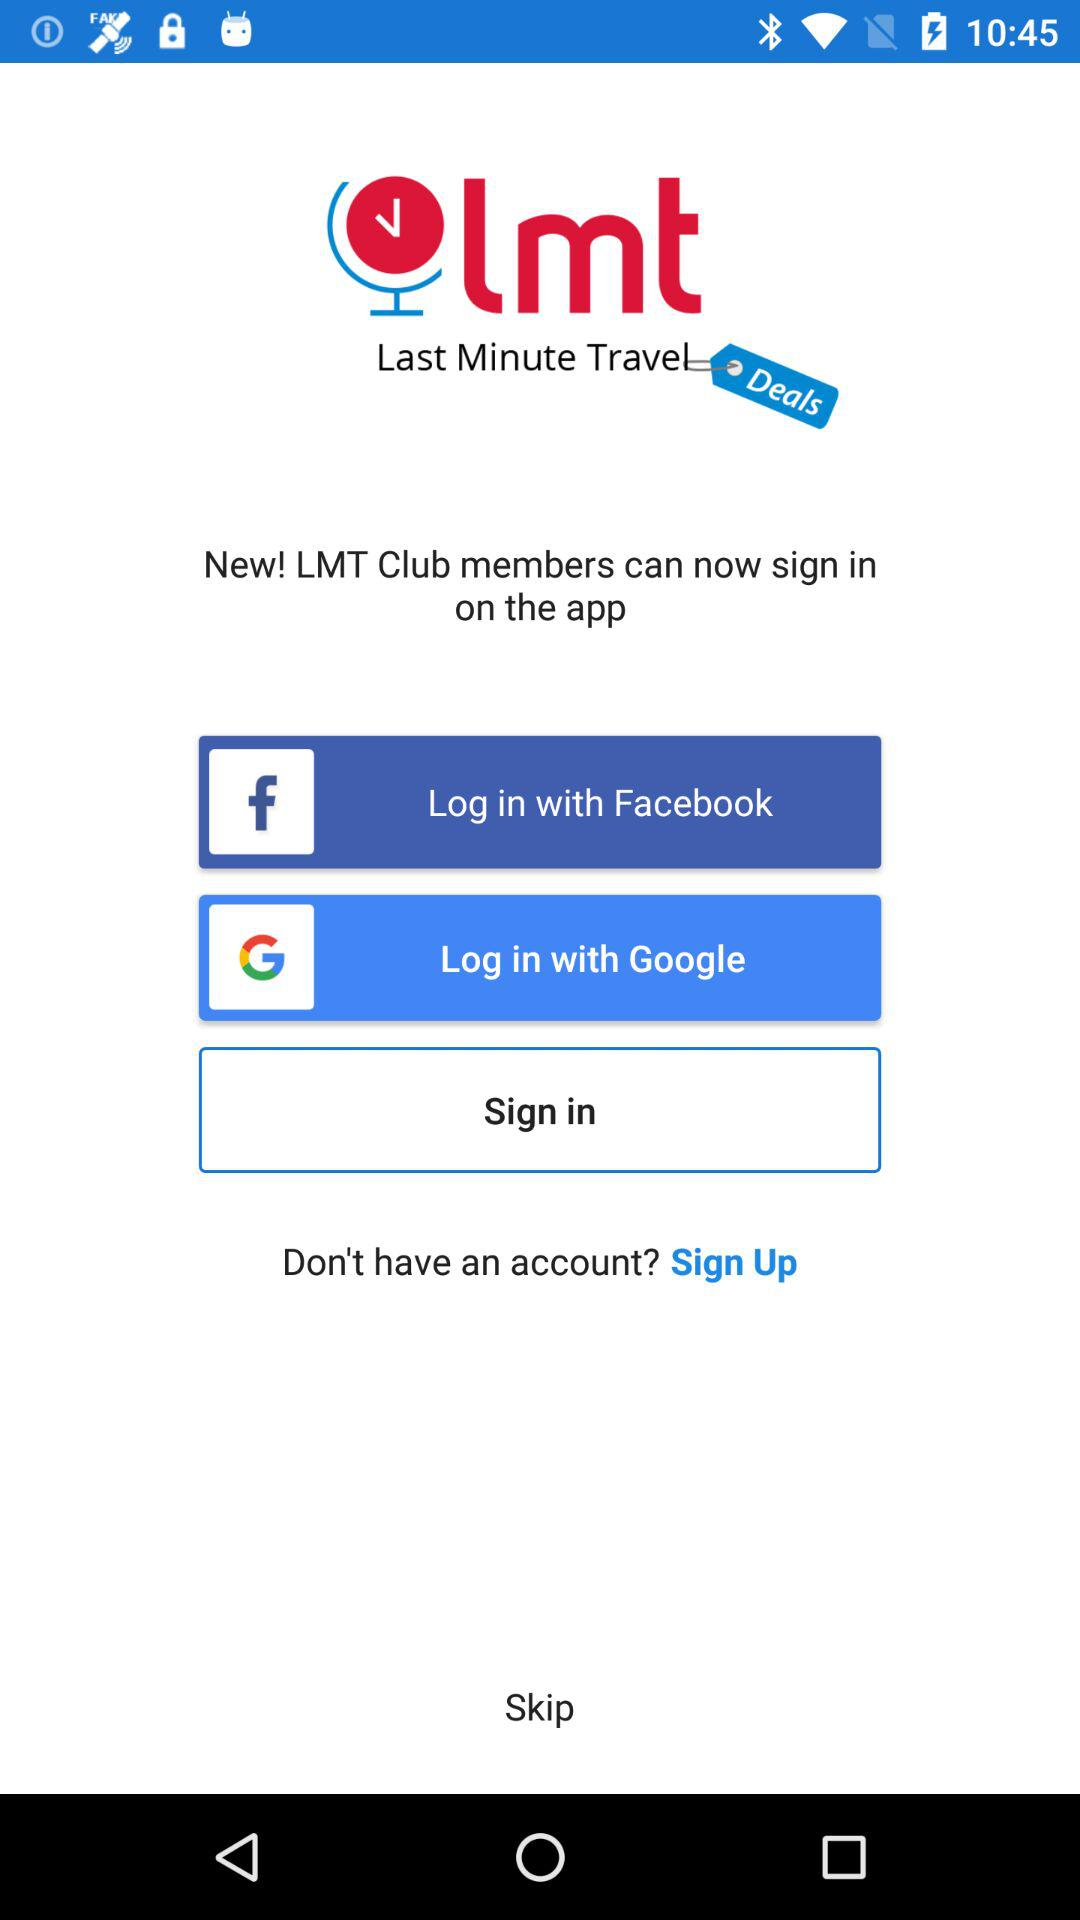How can we log in? You can log in with "Facebook" and "Google". 